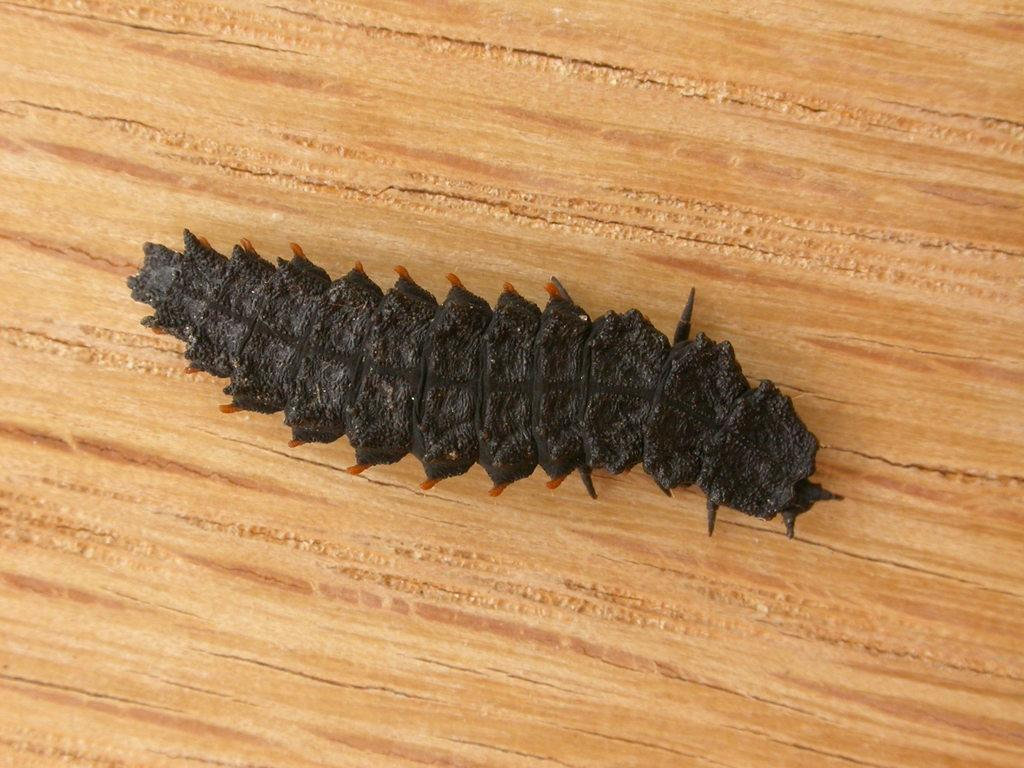What type of creature can be seen in the image? There is an insect in the image. What surface is the insect on? The insect is on wood. What color is the insect? The insect is black in color. How does the insect pull the iron in the image? There is no iron present in the image, and insects do not have the ability to pull objects. 